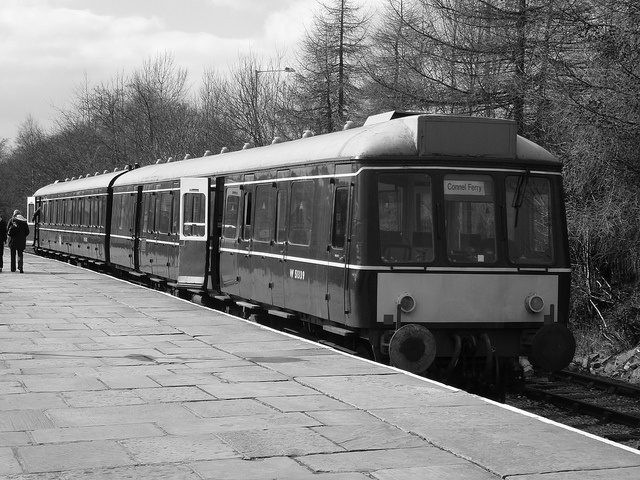Describe the objects in this image and their specific colors. I can see train in white, black, gray, lightgray, and darkgray tones, people in white, black, gray, darkgray, and lightgray tones, backpack in white, black, gray, darkgray, and lightgray tones, and people in white, black, darkgray, lightgray, and gray tones in this image. 